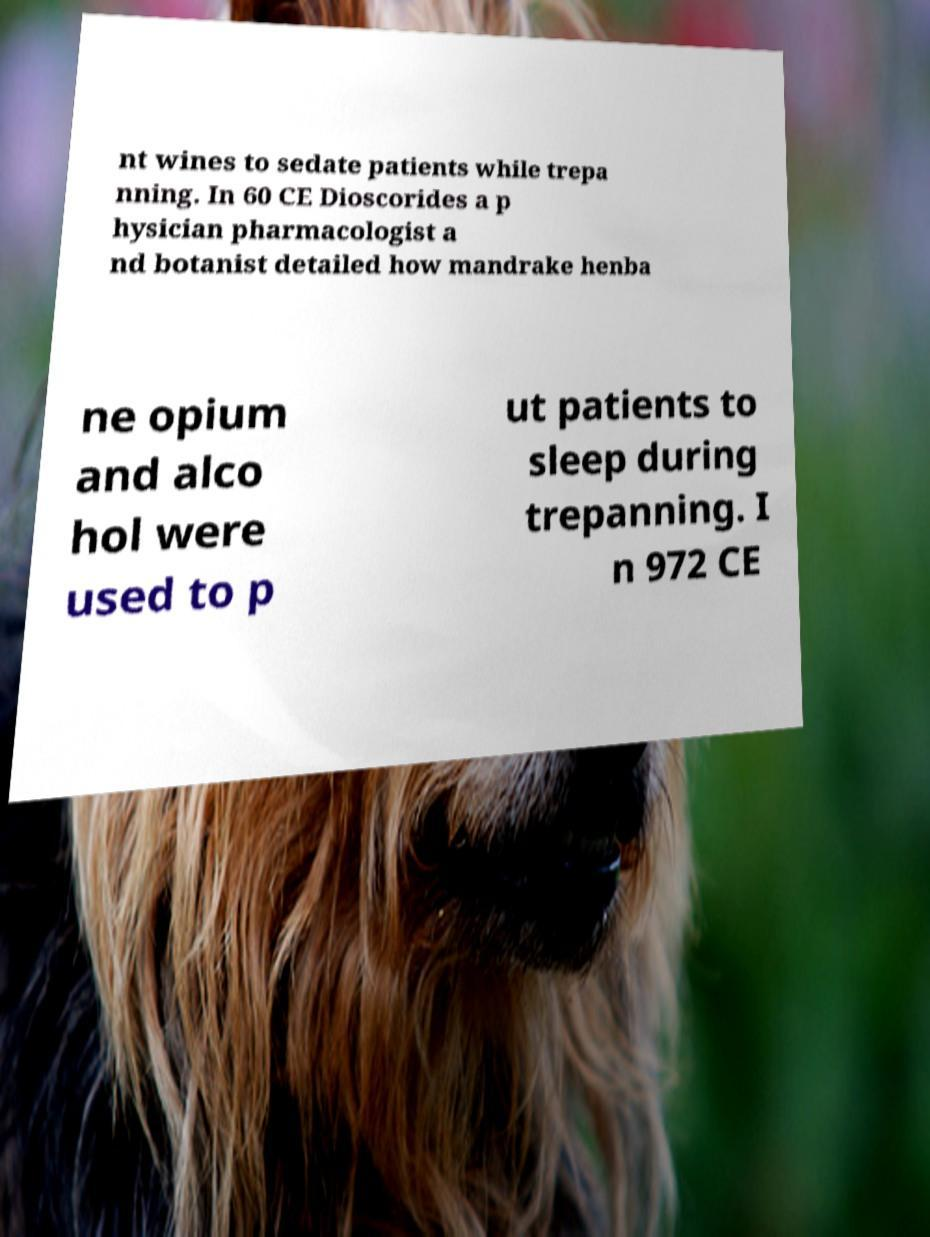Please read and relay the text visible in this image. What does it say? nt wines to sedate patients while trepa nning. In 60 CE Dioscorides a p hysician pharmacologist a nd botanist detailed how mandrake henba ne opium and alco hol were used to p ut patients to sleep during trepanning. I n 972 CE 